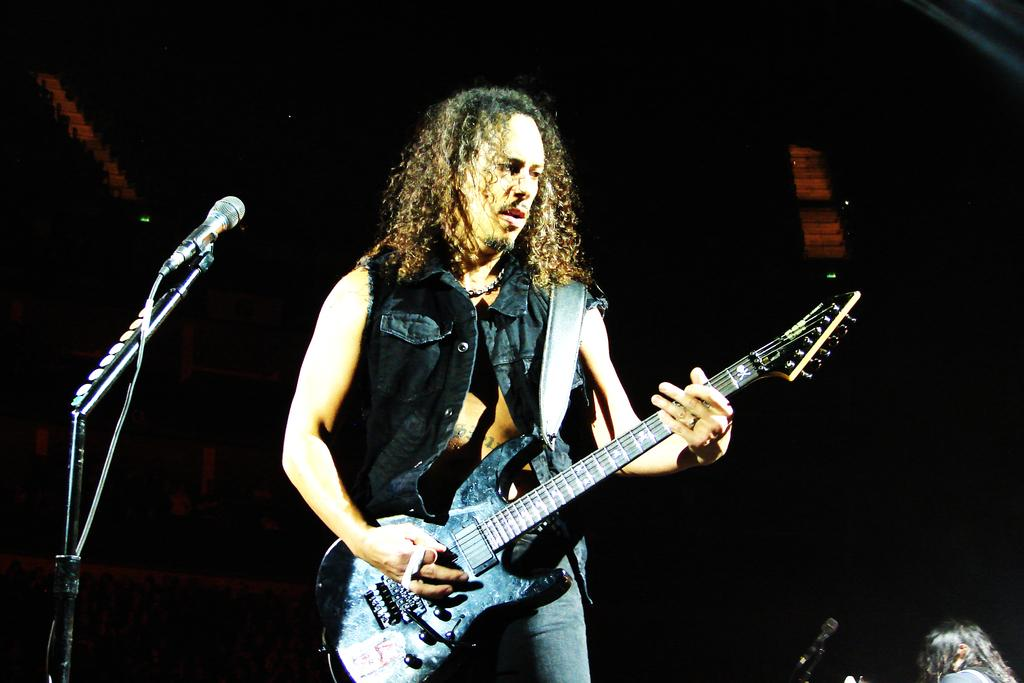What type of event is the image from? The image is from a concert. Can you describe the person in the image? There is a man in the image, and he is wearing a black jacket. What instrument is the man playing? The man is playing a black guitar. What equipment is set up near the man? There is a microphone and mic stand to the left of the man. How would you describe the lighting in the image? The background of the image is dark. What type of hobby does the man have with his collection of jewels in the image? There is no mention of jewels or any hobby related to them in the image. 